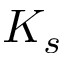Convert formula to latex. <formula><loc_0><loc_0><loc_500><loc_500>K _ { s }</formula> 